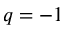Convert formula to latex. <formula><loc_0><loc_0><loc_500><loc_500>q = - 1</formula> 